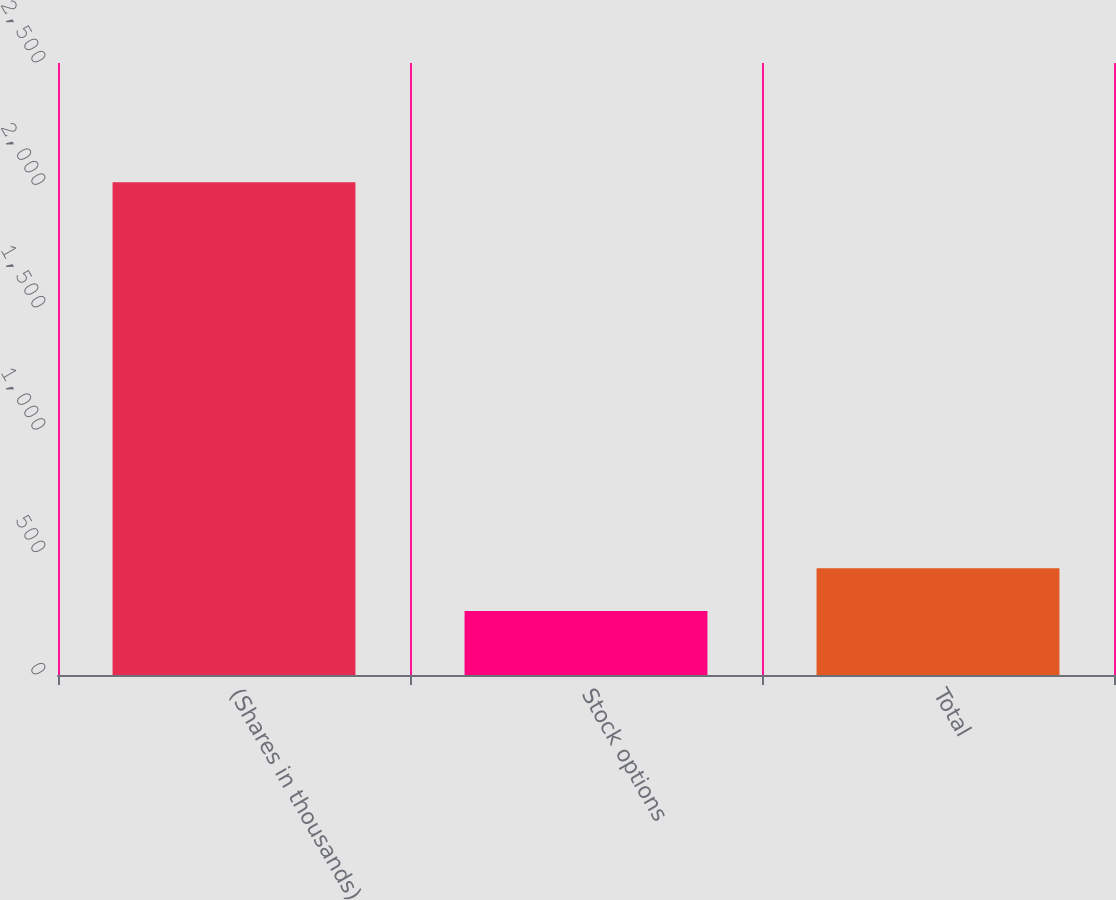Convert chart. <chart><loc_0><loc_0><loc_500><loc_500><bar_chart><fcel>(Shares in thousands)<fcel>Stock options<fcel>Total<nl><fcel>2013<fcel>261<fcel>436.2<nl></chart> 